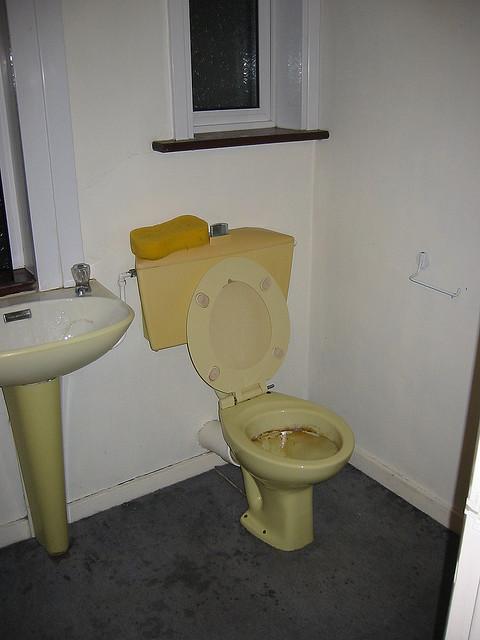Is the seat up?
Concise answer only. Yes. Is there a door?
Keep it brief. No. Does this bathroom have a sink yet?
Concise answer only. Yes. What reflective object is on the wall?
Concise answer only. Mirror. Is this room clean?
Quick response, please. No. Is this in a poor person's home?
Give a very brief answer. Yes. Is the toilet lid up?
Keep it brief. Yes. What is white?
Quick response, please. Walls. What is above the toilet?
Concise answer only. Window. Is the toilet seat up?
Quick response, please. Yes. Are they out of toilet paper?
Give a very brief answer. Yes. What is the floor made out of?
Be succinct. Carpet. What is the object on the right used for?
Short answer required. Peeing. Is the wall tiled?
Short answer required. No. Does this bathroom have a sink?
Concise answer only. Yes. What room is this?
Quick response, please. Bathroom. What color is the toilet?
Give a very brief answer. Yellow. Does this bathroom have a shower?
Be succinct. No. What is the position of the toilet seat lid?
Be succinct. Up. Is this restroom old or new?
Answer briefly. Old. Is this bathroom clean?
Keep it brief. No. What color is the window shelf?
Short answer required. Brown. What is the color of the toilet?
Answer briefly. Yellow. Is it daylight in this picture?
Concise answer only. No. 